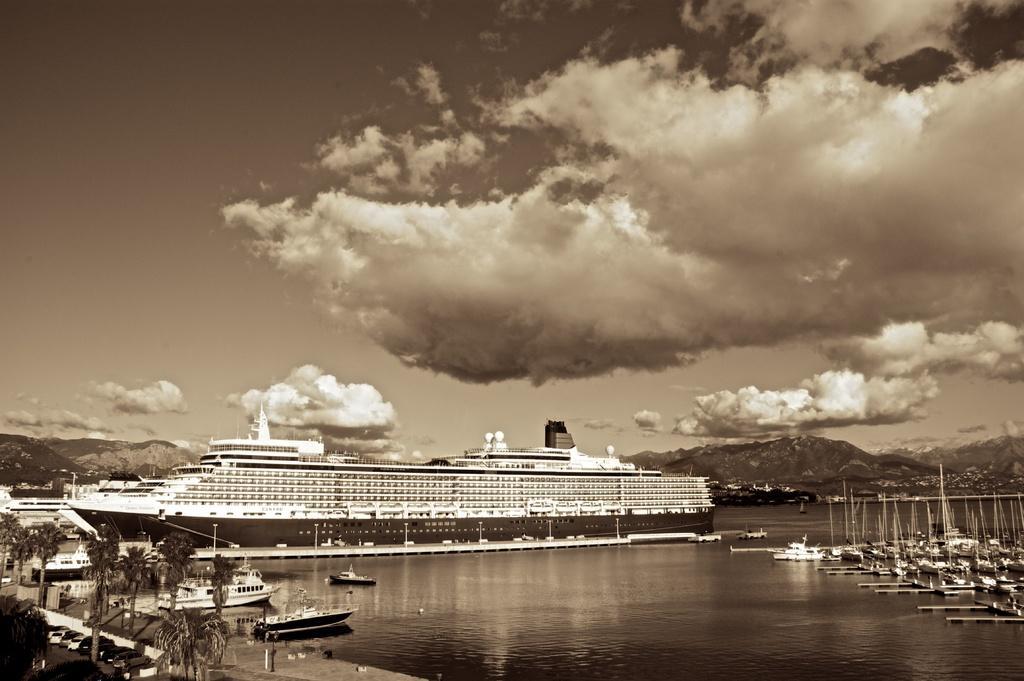How would you summarize this image in a sentence or two? This image consists of a ship. And we can see many boats. At the bottom, there is water. On the left, there are trees. At the top, there are clouds in the sky. 